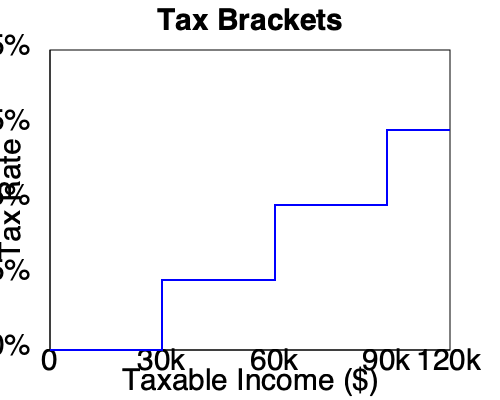Based on the tax bracket graph shown, what would be the marginal tax rate for someone with a taxable income of $75,000? To determine the marginal tax rate for a taxable income of $75,000, we need to follow these steps:

1. Locate $75,000 on the x-axis (Taxable Income).
2. Draw an imaginary vertical line from this point up to where it intersects the blue stepped line.
3. From this intersection point, move horizontally to the left to read the corresponding tax rate on the y-axis.

Looking at the graph:
- $0 to $30,000: 5% tax rate
- $30,000 to $60,000: 15% tax rate
- $60,000 to $90,000: 25% tax rate
- $90,000 and above: 35% tax rate

$75,000 falls in the range between $60,000 and $90,000. Therefore, the marginal tax rate for a taxable income of $75,000 is 25%.

It's important to note that this is the marginal rate, which means it only applies to the portion of income within this bracket. The total tax paid would be calculated using all applicable brackets up to $75,000.
Answer: 25% 